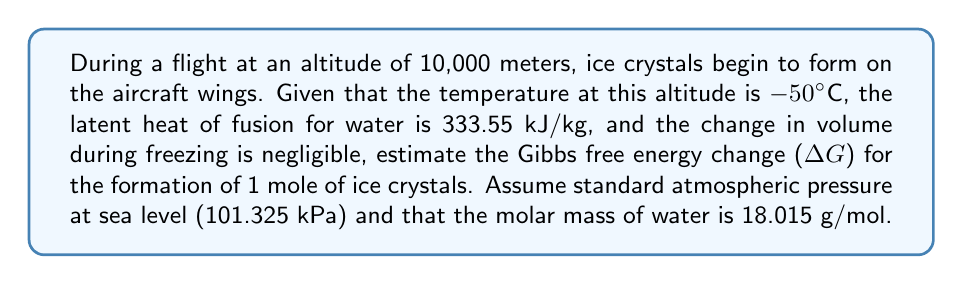Give your solution to this math problem. To estimate the Gibbs free energy change (ΔG) for the formation of ice crystals, we'll use the relationship between ΔG, enthalpy change (ΔH), temperature (T), and entropy change (ΔS):

$$\Delta G = \Delta H - T\Delta S$$

Step 1: Calculate the enthalpy change (ΔH)
The enthalpy change is equal to the latent heat of fusion for water:
$$\Delta H = -333.55 \text{ kJ/kg} \times 0.018015 \text{ kg/mol} = -6.0094 \text{ kJ/mol}$$
(Negative because heat is released during freezing)

Step 2: Estimate the entropy change (ΔS)
For a first approximation, we can use the relationship:
$$\Delta S \approx \frac{\Delta H}{T_m}$$
Where $T_m$ is the melting temperature of water (273.15 K)

$$\Delta S \approx \frac{-6.0094 \text{ kJ/mol}}{273.15 \text{ K}} = -0.022 \text{ kJ/(mol·K)}$$

Step 3: Calculate ΔG using the given temperature
T = -50°C + 273.15 = 223.15 K

$$\begin{align*}
\Delta G &= \Delta H - T\Delta S \\
&= -6.0094 \text{ kJ/mol} - 223.15 \text{ K} \times (-0.022 \text{ kJ/(mol·K)}) \\
&= -6.0094 \text{ kJ/mol} + 4.9093 \text{ kJ/mol} \\
&= -1.1001 \text{ kJ/mol}
\end{align*}$$

Step 4: Convert to J/mol for a more precise answer
$$\Delta G = -1100.1 \text{ J/mol}$$
Answer: $-1100.1 \text{ J/mol}$ 